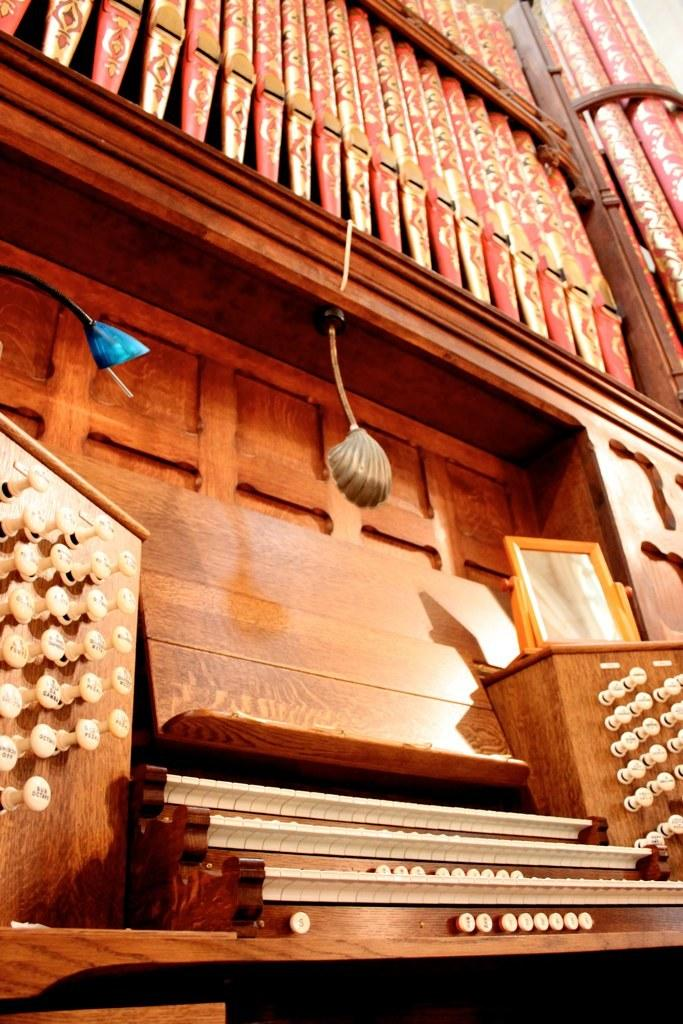What can be seen on the right side of the image? There are steps on the right side of the image. What surrounds the steps in the image? There is a fence on both sides of the steps. What is placed on the fence? There are objects on the fence. What is above the steps in the image? There are two lights above the steps. What type of glass is used to make the motion-sensitive bulbs on the fence? There is no mention of glass or motion-sensitive bulbs in the image; the facts only mention a fence with objects on it and two lights above the steps. 